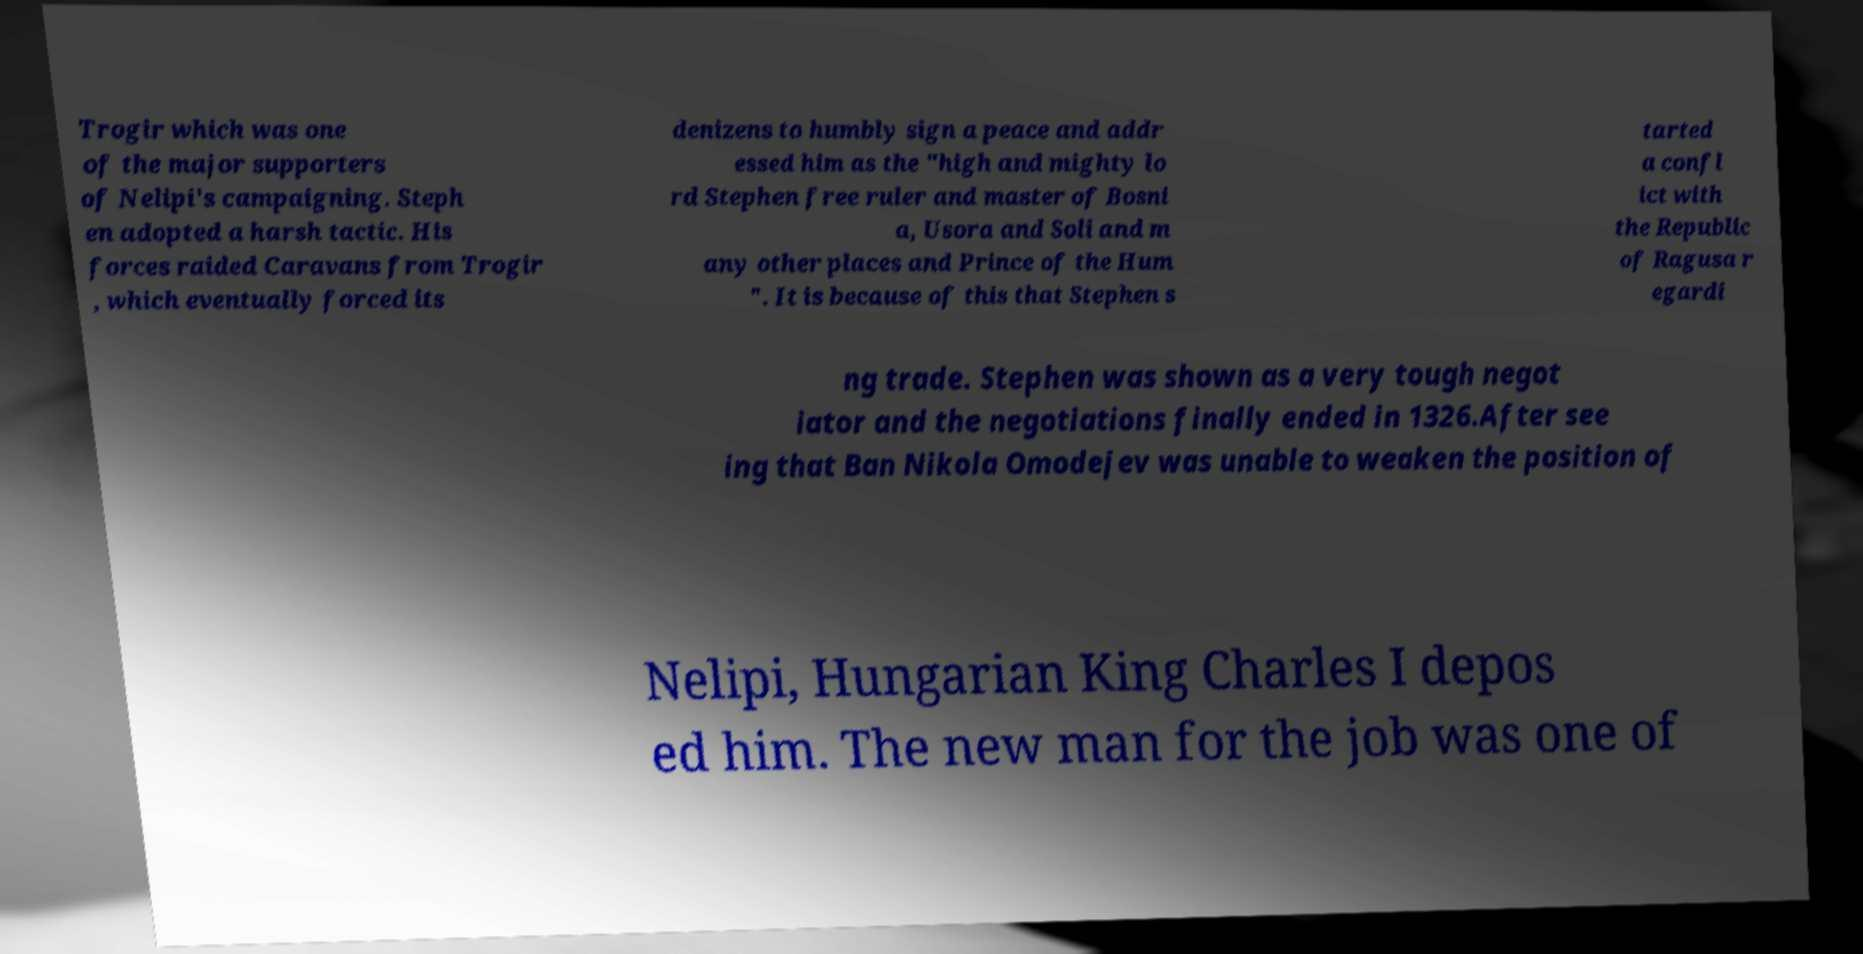What messages or text are displayed in this image? I need them in a readable, typed format. Trogir which was one of the major supporters of Nelipi's campaigning. Steph en adopted a harsh tactic. His forces raided Caravans from Trogir , which eventually forced its denizens to humbly sign a peace and addr essed him as the "high and mighty lo rd Stephen free ruler and master of Bosni a, Usora and Soli and m any other places and Prince of the Hum ". It is because of this that Stephen s tarted a confl ict with the Republic of Ragusa r egardi ng trade. Stephen was shown as a very tough negot iator and the negotiations finally ended in 1326.After see ing that Ban Nikola Omodejev was unable to weaken the position of Nelipi, Hungarian King Charles I depos ed him. The new man for the job was one of 